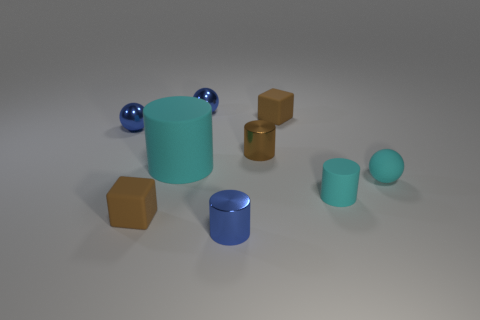How many tiny metal objects are the same color as the matte ball?
Give a very brief answer. 0. There is a cyan matte object that is left of the blue metal thing that is in front of the cyan ball; what is its size?
Offer a terse response. Large. There is a large rubber thing; is it the same color as the tiny sphere that is in front of the tiny brown metallic cylinder?
Your answer should be very brief. Yes. Is there a cyan metal ball that has the same size as the blue shiny cylinder?
Keep it short and to the point. No. There is a cyan thing on the left side of the blue metal cylinder; what is its size?
Provide a succinct answer. Large. Is there a brown matte block to the left of the rubber block in front of the big rubber thing?
Your answer should be very brief. No. What number of other objects are there of the same shape as the large thing?
Provide a short and direct response. 3. Is the shape of the large rubber thing the same as the brown shiny object?
Provide a short and direct response. Yes. The tiny sphere that is behind the large cyan rubber cylinder and right of the big cylinder is what color?
Ensure brevity in your answer.  Blue. There is another cylinder that is the same color as the big cylinder; what is its size?
Offer a very short reply. Small. 